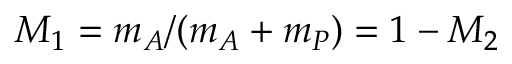Convert formula to latex. <formula><loc_0><loc_0><loc_500><loc_500>M _ { 1 } = m _ { A } / ( m _ { A } + m _ { P } ) = 1 - M _ { 2 }</formula> 